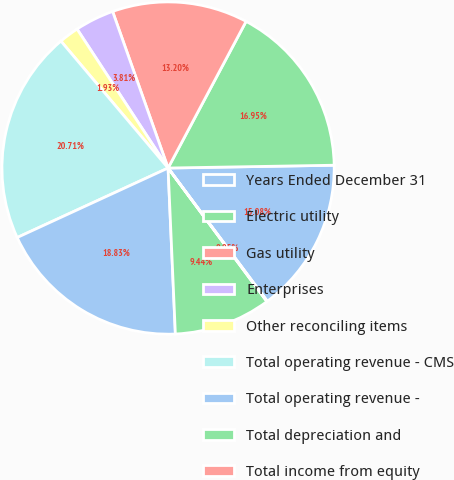<chart> <loc_0><loc_0><loc_500><loc_500><pie_chart><fcel>Years Ended December 31<fcel>Electric utility<fcel>Gas utility<fcel>Enterprises<fcel>Other reconciling items<fcel>Total operating revenue - CMS<fcel>Total operating revenue -<fcel>Total depreciation and<fcel>Total income from equity<nl><fcel>15.08%<fcel>16.95%<fcel>13.2%<fcel>3.81%<fcel>1.93%<fcel>20.71%<fcel>18.83%<fcel>9.44%<fcel>0.05%<nl></chart> 